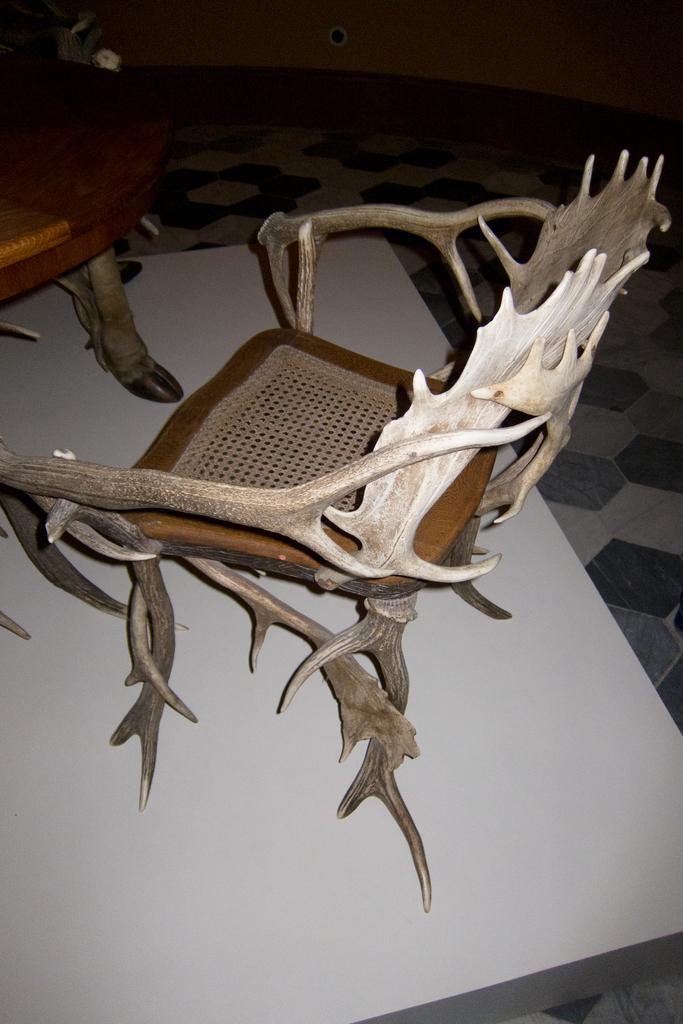Please provide a concise description of this image. In this picture we can see two chairs on the surface. In the background we can see the floor and the wall. 